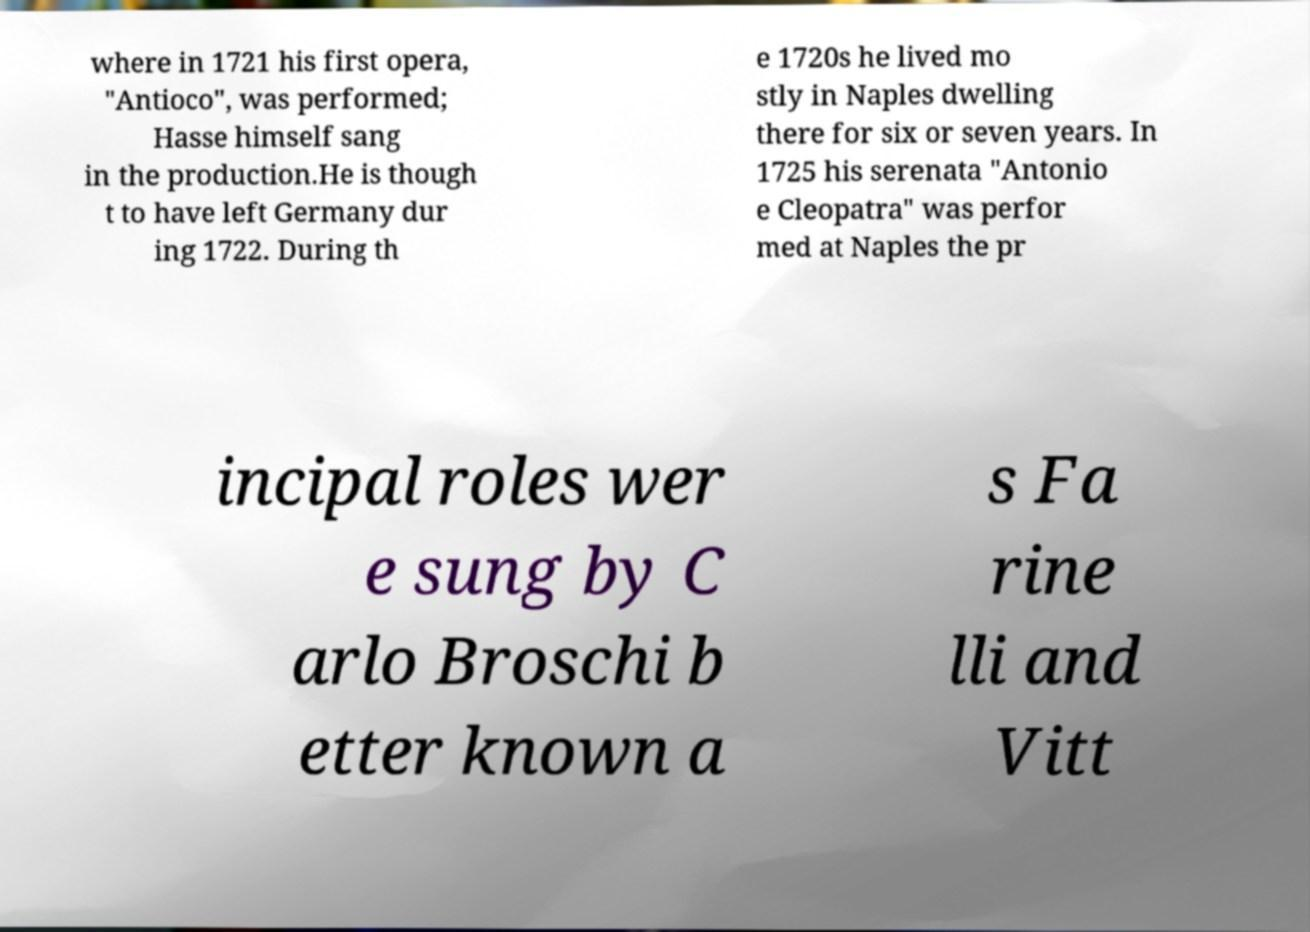What messages or text are displayed in this image? I need them in a readable, typed format. where in 1721 his first opera, "Antioco", was performed; Hasse himself sang in the production.He is though t to have left Germany dur ing 1722. During th e 1720s he lived mo stly in Naples dwelling there for six or seven years. In 1725 his serenata "Antonio e Cleopatra" was perfor med at Naples the pr incipal roles wer e sung by C arlo Broschi b etter known a s Fa rine lli and Vitt 